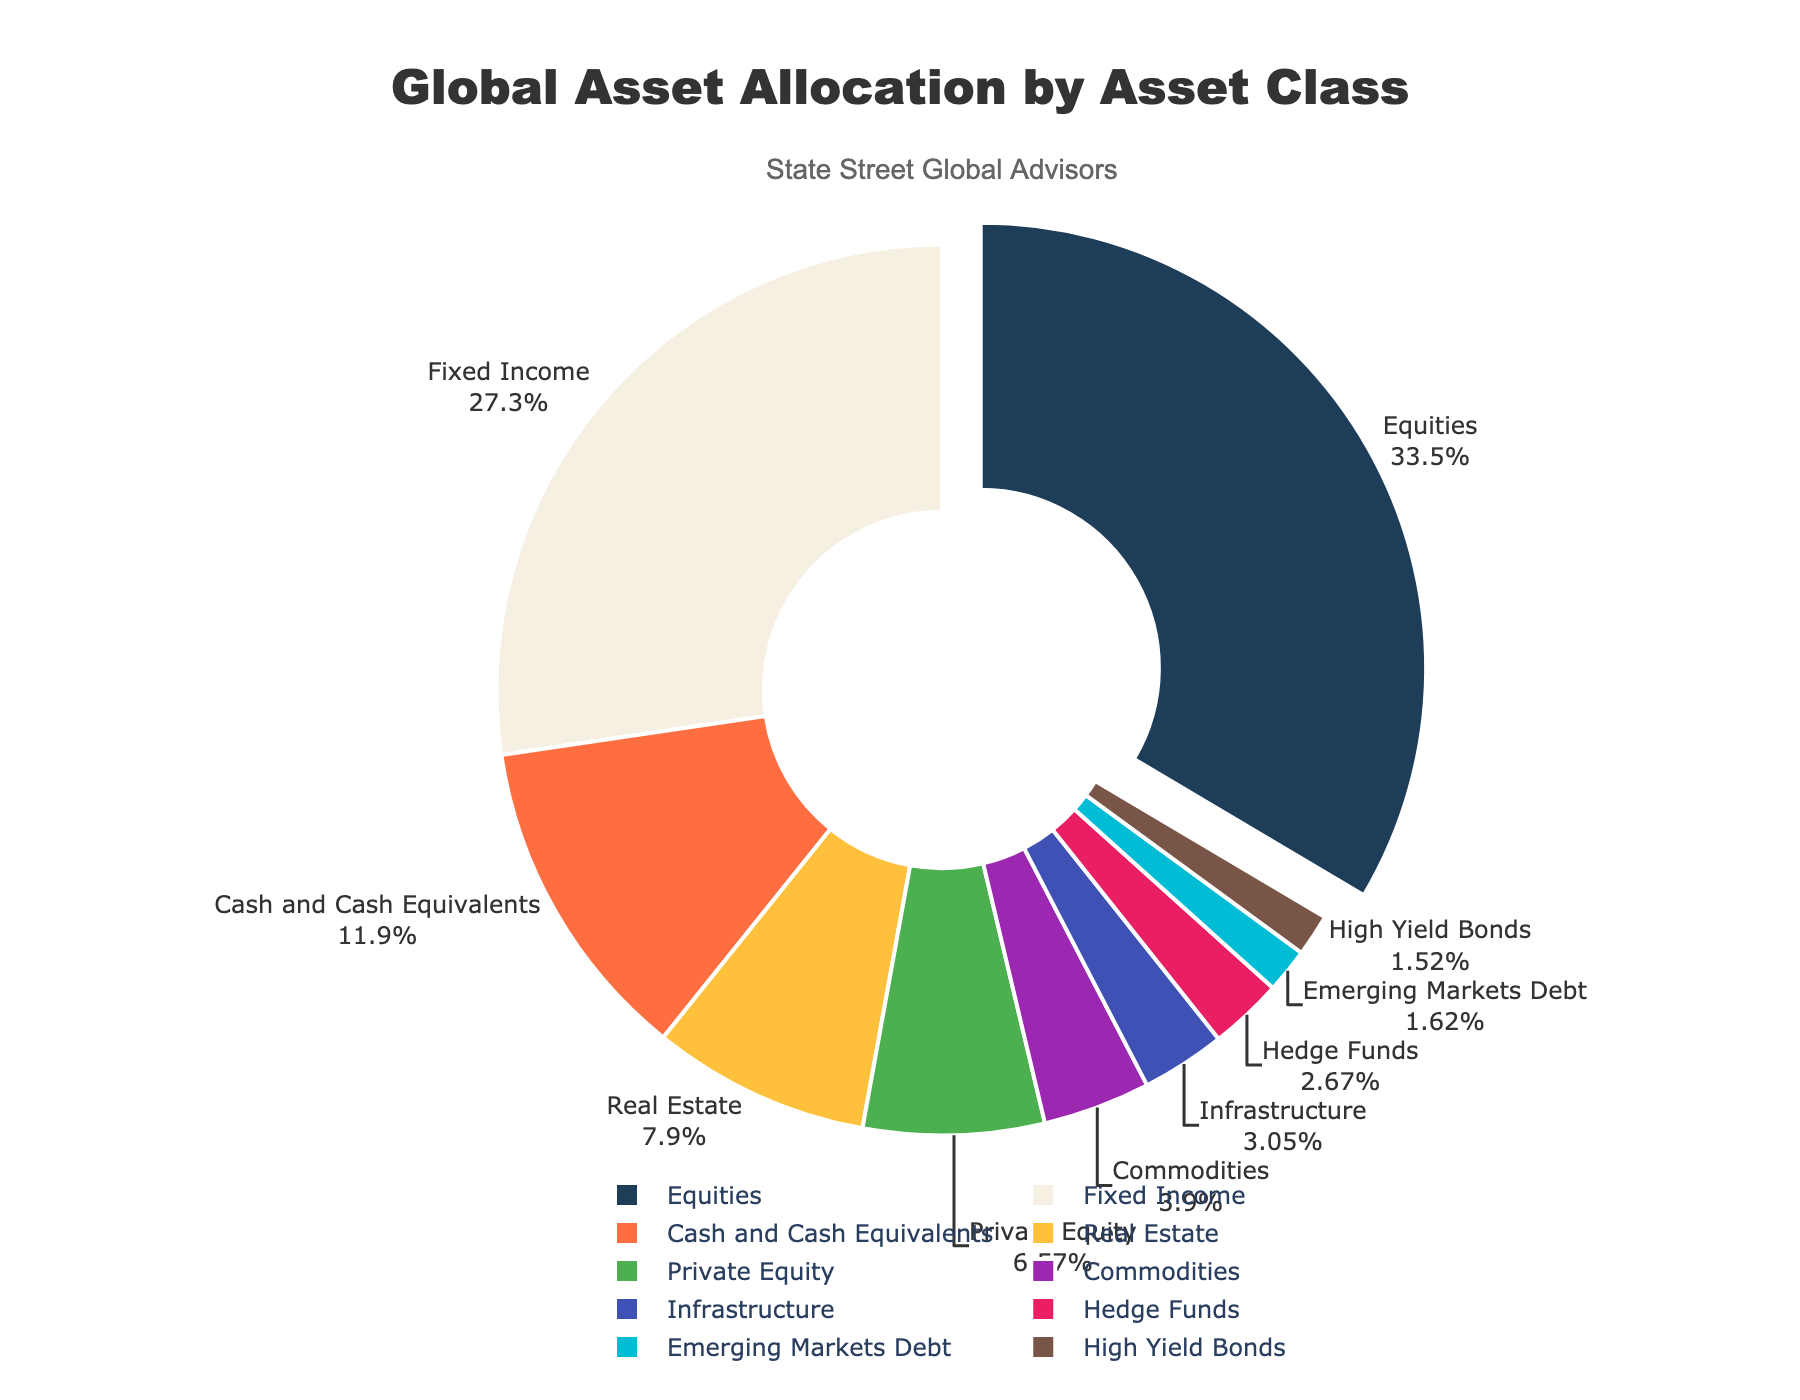What is the largest asset class by percentage? The figure shows the percentage of each asset class. The largest percentage is for Equities, which is 35.2%.
Answer: Equities What is the total percentage of Equities and Fixed Income? The figure shows Equities as 35.2% and Fixed Income as 28.7%. Summing them up, 35.2 + 28.7 = 63.9%.
Answer: 63.9% Which asset class represents a smaller percentage, Infrastructure or Commodities? The figure shows Infrastructure at 3.2% and Commodities at 4.1%. Since 3.2% is smaller than 4.1%, Infrastructure represents a smaller percentage.
Answer: Infrastructure How much greater is the percentage of Cash and Cash Equivalents compared to Hedge Funds? The figure shows Cash and Cash Equivalents at 12.5% and Hedge Funds at 2.8%. Subtracting these, 12.5 - 2.8 = 9.7%.
Answer: 9.7% What's the combined percentage of the smallest three asset classes listed? The figure shows the smallest three asset classes as Emerging Markets Debt (1.7%), High Yield Bonds (1.6%), and Hedge Funds (2.8%). Summing them up, 1.7 + 1.6 + 2.8 = 6.1%.
Answer: 6.1% Which asset class has the yellow segment in the pie chart? By referring to the colors assigned in the plot, the yellow segment corresponds to Real Estate.
Answer: Real Estate What is the sum of the percentages of all asset classes that have a percentage greater than or equal to 10%? The figure shows Equities (35.2%) and Fixed Income (28.7%) and Cash and Cash Equivalents (12.5%). Summing them up, 35.2 + 28.7 + 12.5 = 76.4%.
Answer: 76.4% What percentage is represented by asset classes other than Equities? The total percentage must be 100%. Equities represent 35.2%, so the other classes represent 100 - 35.2 = 64.8%.
Answer: 64.8% Which asset class occupies the smallest segment in the pie chart? The figure shows that High Yield Bonds have the smallest percentage of 1.6%.
Answer: High Yield Bonds 